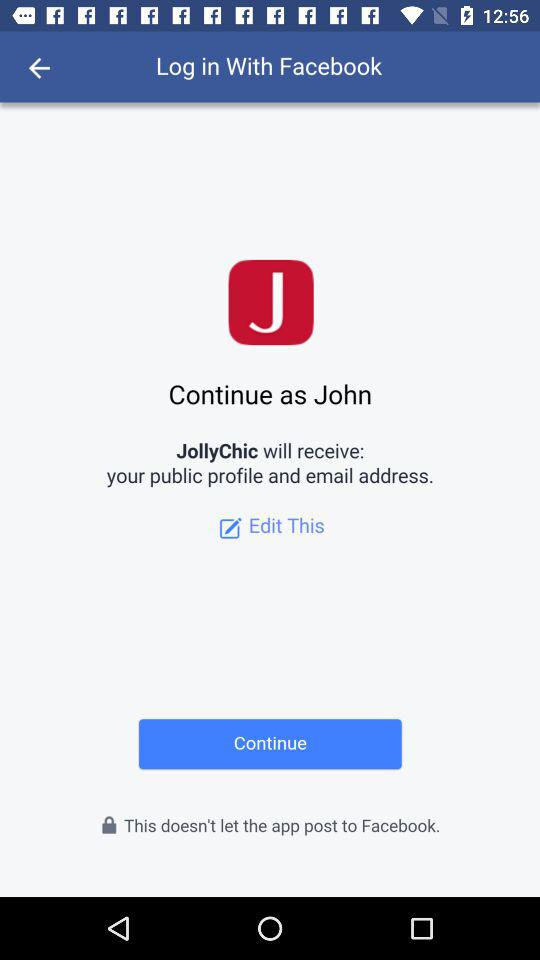What is the username? The username is John. 